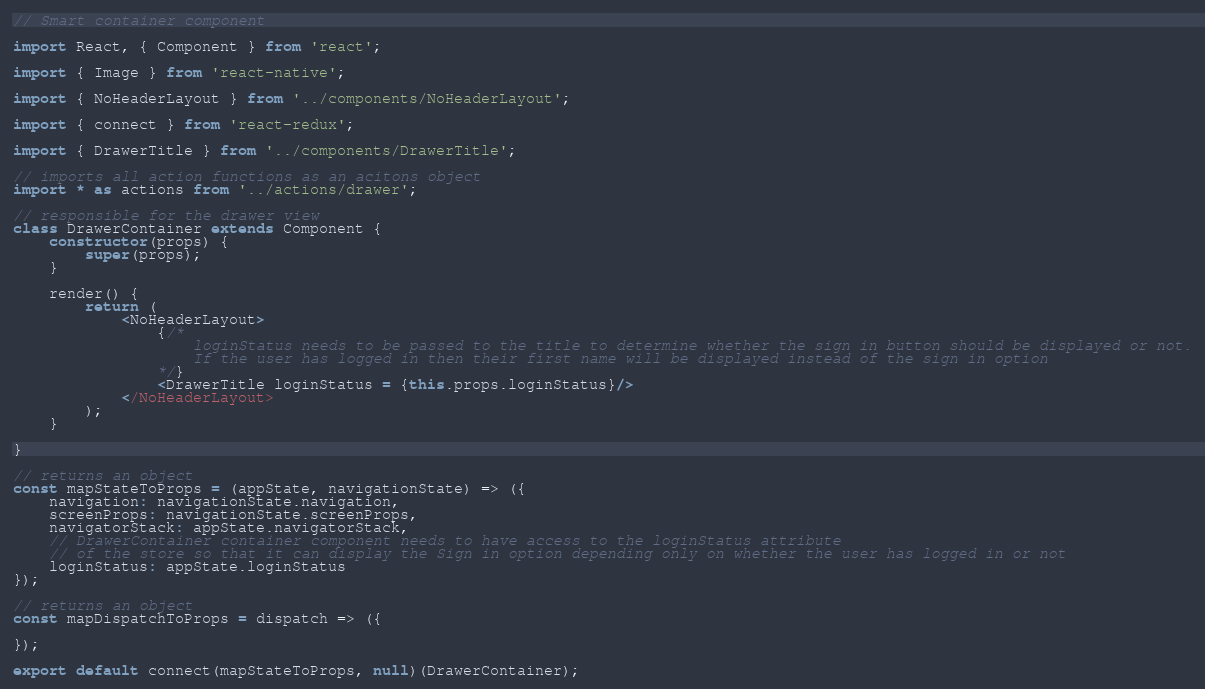<code> <loc_0><loc_0><loc_500><loc_500><_JavaScript_>// Smart container component

import React, { Component } from 'react';

import { Image } from 'react-native';

import { NoHeaderLayout } from '../components/NoHeaderLayout';

import { connect } from 'react-redux';

import { DrawerTitle } from '../components/DrawerTitle';

// imports all action functions as an acitons object
import * as actions from '../actions/drawer';

// responsible for the drawer view
class DrawerContainer extends Component {
    constructor(props) {
        super(props);
    }

    render() {
        return (
            <NoHeaderLayout>
                {/* 
                    loginStatus needs to be passed to the title to determine whether the sign in button should be displayed or not.
                    If the user has logged in then their first name will be displayed instead of the sign in option
                */}
                <DrawerTitle loginStatus = {this.props.loginStatus}/>
            </NoHeaderLayout>
        );
    }

}

// returns an object
const mapStateToProps = (appState, navigationState) => ({
    navigation: navigationState.navigation,
    screenProps: navigationState.screenProps,
    navigatorStack: appState.navigatorStack,
    // DrawerContainer container component needs to have access to the loginStatus attribute
    // of the store so that it can display the Sign in option depending only on whether the user has logged in or not
    loginStatus: appState.loginStatus
});

// returns an object
const mapDispatchToProps = dispatch => ({

});

export default connect(mapStateToProps, null)(DrawerContainer);
</code> 